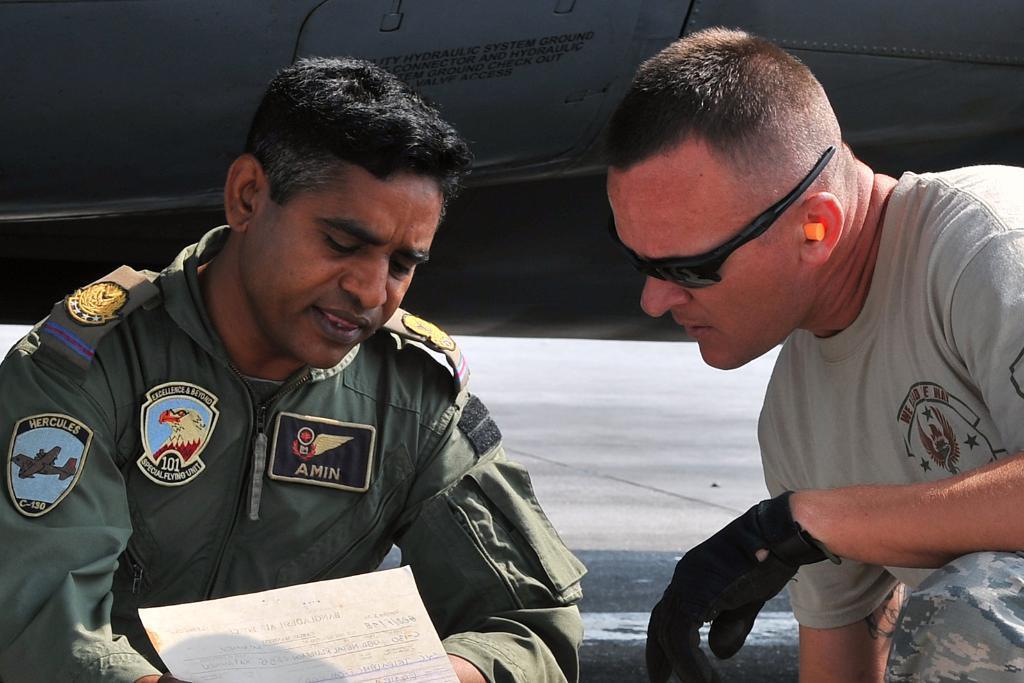Describe this image in one or two sentences. On the left side, there is a person in a uniform, holding a document and speaking. On the right side, there is a person in a gray color T-Shirt, wearing sunglasses and black color glove and watching a paper. In the background, there is a vehicle and there is a road. 